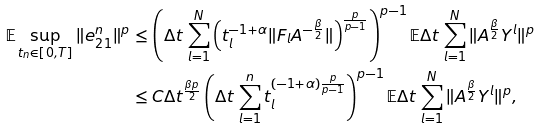<formula> <loc_0><loc_0><loc_500><loc_500>\mathbb { E } \sup _ { t _ { n } \in [ 0 , T ] } \| e ^ { n } _ { 2 1 } \| ^ { p } & \leq \left ( \Delta t \, \sum _ { l = 1 } ^ { N } \left ( t _ { l } ^ { - 1 + \alpha } \| F _ { l } A ^ { - \frac { \beta } { 2 } } \| \right ) ^ { \frac { p } { p - 1 } } \right ) ^ { p - 1 } \mathbb { E } \Delta t \, \sum _ { l = 1 } ^ { N } \| A ^ { \frac { \beta } { 2 } } Y ^ { l } \| ^ { p } \\ & \leq C \Delta t ^ { \frac { \beta p } { 2 } } \left ( \Delta t \, \sum _ { l = 1 } ^ { n } t _ { l } ^ { ( - 1 + \alpha ) \frac { p } { p - 1 } } \right ) ^ { p - 1 } \mathbb { E } \Delta t \, \sum _ { l = 1 } ^ { N } \| A ^ { \frac { \beta } { 2 } } Y ^ { l } \| ^ { p } ,</formula> 